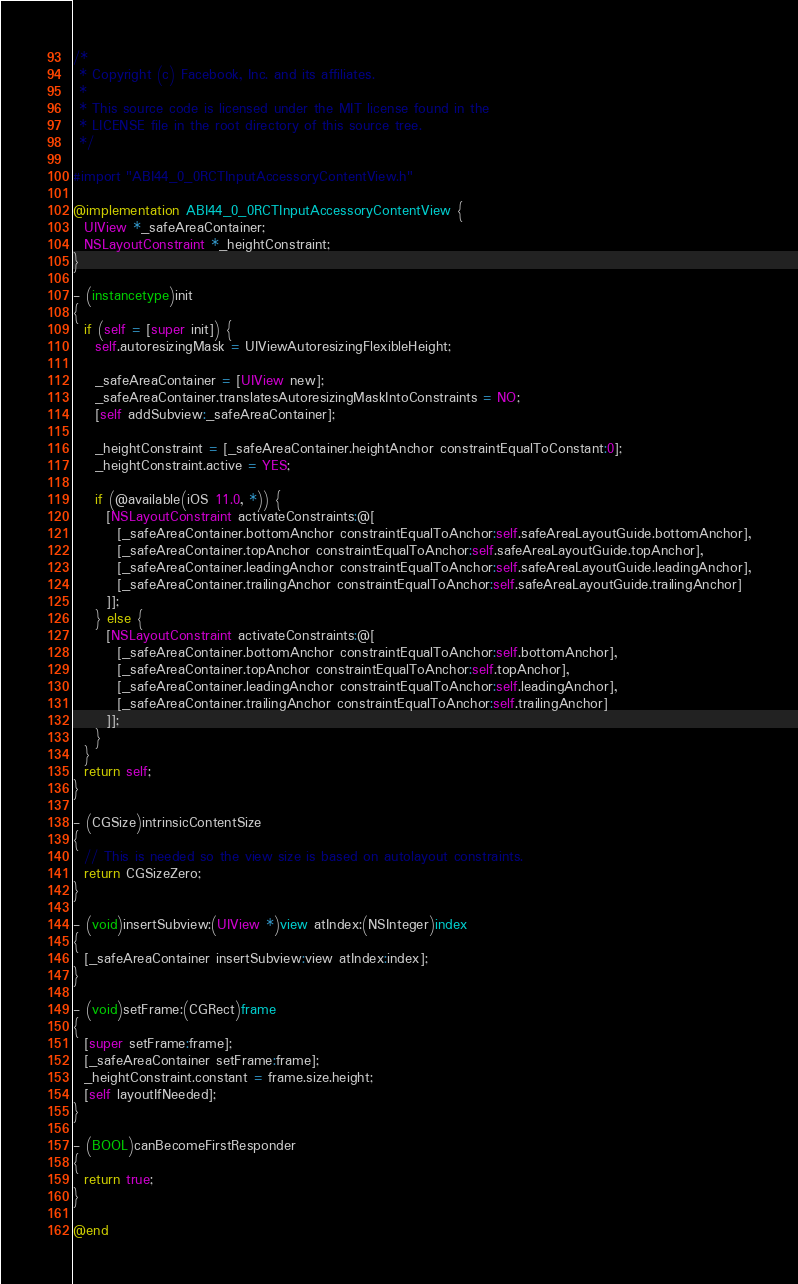<code> <loc_0><loc_0><loc_500><loc_500><_ObjectiveC_>/*
 * Copyright (c) Facebook, Inc. and its affiliates.
 *
 * This source code is licensed under the MIT license found in the
 * LICENSE file in the root directory of this source tree.
 */

#import "ABI44_0_0RCTInputAccessoryContentView.h"

@implementation ABI44_0_0RCTInputAccessoryContentView {
  UIView *_safeAreaContainer;
  NSLayoutConstraint *_heightConstraint;
}

- (instancetype)init
{
  if (self = [super init]) {
    self.autoresizingMask = UIViewAutoresizingFlexibleHeight;

    _safeAreaContainer = [UIView new];
    _safeAreaContainer.translatesAutoresizingMaskIntoConstraints = NO;
    [self addSubview:_safeAreaContainer];

    _heightConstraint = [_safeAreaContainer.heightAnchor constraintEqualToConstant:0];
    _heightConstraint.active = YES;

    if (@available(iOS 11.0, *)) {
      [NSLayoutConstraint activateConstraints:@[
        [_safeAreaContainer.bottomAnchor constraintEqualToAnchor:self.safeAreaLayoutGuide.bottomAnchor],
        [_safeAreaContainer.topAnchor constraintEqualToAnchor:self.safeAreaLayoutGuide.topAnchor],
        [_safeAreaContainer.leadingAnchor constraintEqualToAnchor:self.safeAreaLayoutGuide.leadingAnchor],
        [_safeAreaContainer.trailingAnchor constraintEqualToAnchor:self.safeAreaLayoutGuide.trailingAnchor]
      ]];
    } else {
      [NSLayoutConstraint activateConstraints:@[
        [_safeAreaContainer.bottomAnchor constraintEqualToAnchor:self.bottomAnchor],
        [_safeAreaContainer.topAnchor constraintEqualToAnchor:self.topAnchor],
        [_safeAreaContainer.leadingAnchor constraintEqualToAnchor:self.leadingAnchor],
        [_safeAreaContainer.trailingAnchor constraintEqualToAnchor:self.trailingAnchor]
      ]];
    }
  }
  return self;
}

- (CGSize)intrinsicContentSize
{
  // This is needed so the view size is based on autolayout constraints.
  return CGSizeZero;
}

- (void)insertSubview:(UIView *)view atIndex:(NSInteger)index
{
  [_safeAreaContainer insertSubview:view atIndex:index];
}

- (void)setFrame:(CGRect)frame
{
  [super setFrame:frame];
  [_safeAreaContainer setFrame:frame];
  _heightConstraint.constant = frame.size.height;
  [self layoutIfNeeded];
}

- (BOOL)canBecomeFirstResponder
{
  return true;
}

@end
</code> 